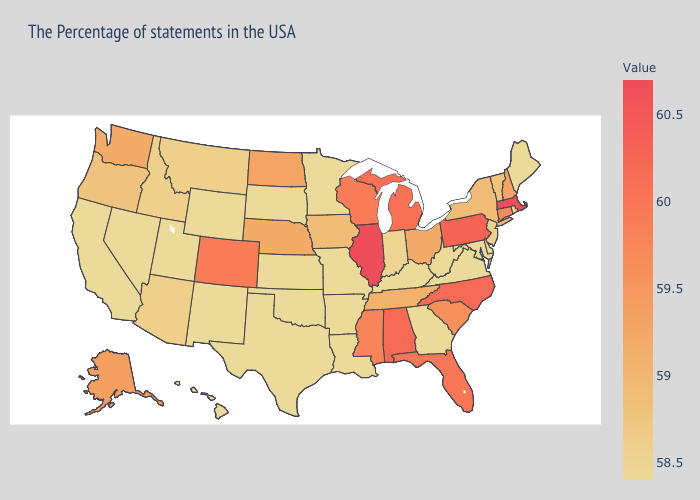Does Missouri have the lowest value in the USA?
Answer briefly. Yes. Does the map have missing data?
Short answer required. No. Does Rhode Island have the lowest value in the Northeast?
Short answer required. No. Is the legend a continuous bar?
Give a very brief answer. Yes. Among the states that border Georgia , does South Carolina have the lowest value?
Keep it brief. No. 